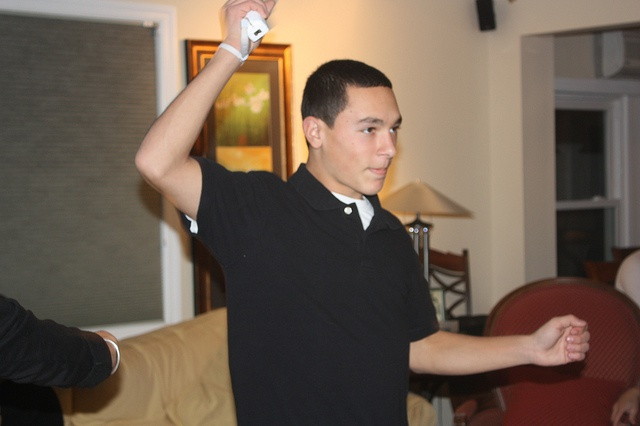Describe the objects in this image and their specific colors. I can see people in darkgray, black, tan, and gray tones, chair in darkgray, maroon, black, and gray tones, couch in darkgray, gray, tan, black, and maroon tones, people in darkgray, black, and gray tones, and people in darkgray, gray, maroon, and black tones in this image. 